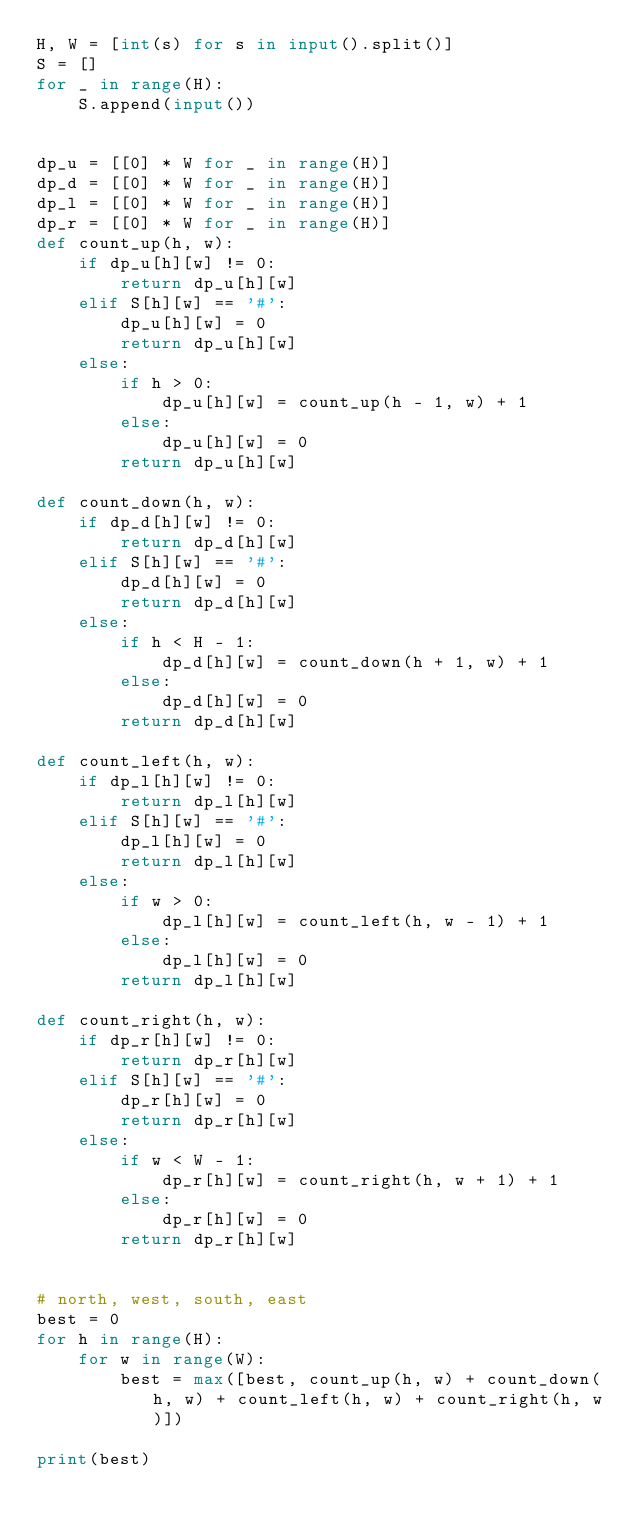<code> <loc_0><loc_0><loc_500><loc_500><_Python_>H, W = [int(s) for s in input().split()]
S = []
for _ in range(H):
    S.append(input())


dp_u = [[0] * W for _ in range(H)]
dp_d = [[0] * W for _ in range(H)]
dp_l = [[0] * W for _ in range(H)]
dp_r = [[0] * W for _ in range(H)]
def count_up(h, w):
    if dp_u[h][w] != 0:
        return dp_u[h][w]
    elif S[h][w] == '#':
        dp_u[h][w] = 0
        return dp_u[h][w]
    else:
        if h > 0:
            dp_u[h][w] = count_up(h - 1, w) + 1
        else:
            dp_u[h][w] = 0
        return dp_u[h][w]

def count_down(h, w):
    if dp_d[h][w] != 0:
        return dp_d[h][w]
    elif S[h][w] == '#':
        dp_d[h][w] = 0
        return dp_d[h][w]
    else:
        if h < H - 1:
            dp_d[h][w] = count_down(h + 1, w) + 1
        else:
            dp_d[h][w] = 0
        return dp_d[h][w]

def count_left(h, w):
    if dp_l[h][w] != 0:
        return dp_l[h][w]
    elif S[h][w] == '#':
        dp_l[h][w] = 0
        return dp_l[h][w]
    else:
        if w > 0:
            dp_l[h][w] = count_left(h, w - 1) + 1
        else:
            dp_l[h][w] = 0
        return dp_l[h][w]

def count_right(h, w):
    if dp_r[h][w] != 0:
        return dp_r[h][w]
    elif S[h][w] == '#':
        dp_r[h][w] = 0
        return dp_r[h][w]
    else:
        if w < W - 1:
            dp_r[h][w] = count_right(h, w + 1) + 1
        else:
            dp_r[h][w] = 0
        return dp_r[h][w]


# north, west, south, east
best = 0
for h in range(H):
    for w in range(W):
        best = max([best, count_up(h, w) + count_down(h, w) + count_left(h, w) + count_right(h, w)])

print(best)
</code> 